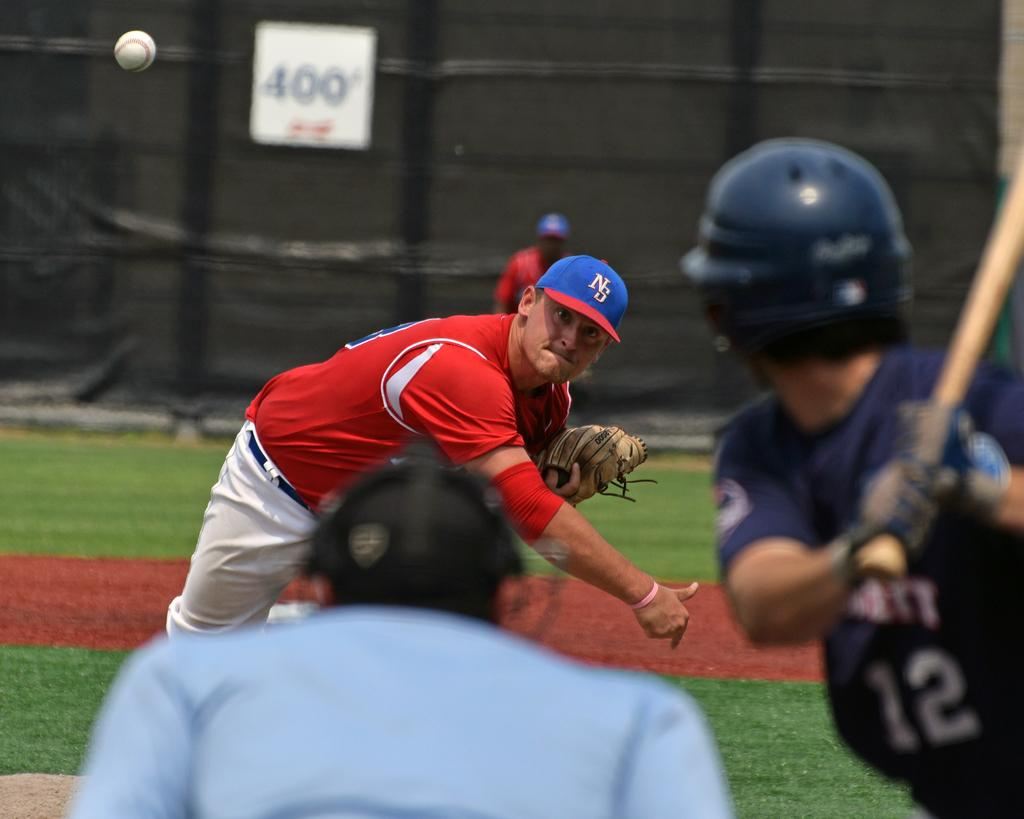How many people are on the ground in the image? There are three persons on the ground in the image. What is one person holding in the image? One person is holding a bat in the image. What is the other person doing in the image? Another person is throwing a ball in the image. Can you describe the background of the image? The background is blurred, and a person and a board are visible. What type of cave can be seen in the background of the image? There is no cave present in the image; the background is blurred and features a person and a board. What statement is being made by the person in the background? There is no statement being made by the person in the background, as the image does not show any text or speech. 